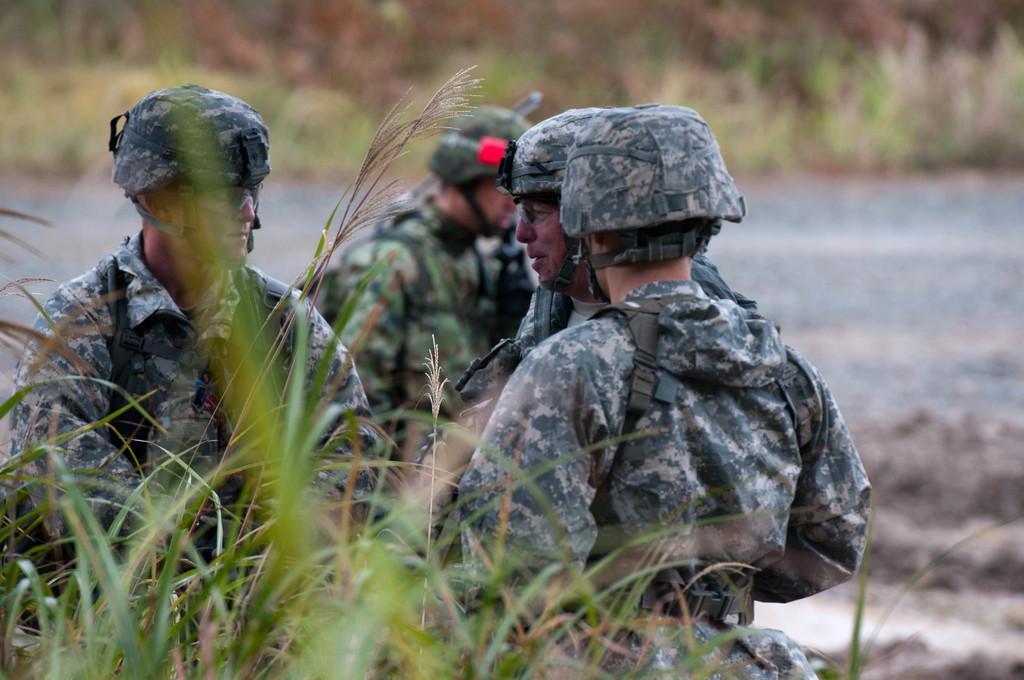How would you summarize this image in a sentence or two? In this image there are four men standing. They are wearing an uniform. They seem to be soldiers. In the foreground there is grass. Behind them there is water. The background is blurry. 